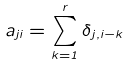Convert formula to latex. <formula><loc_0><loc_0><loc_500><loc_500>a _ { j i } = \sum _ { k = 1 } ^ { r } \delta _ { j , i - k }</formula> 